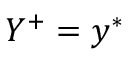<formula> <loc_0><loc_0><loc_500><loc_500>Y ^ { + } = y ^ { * }</formula> 